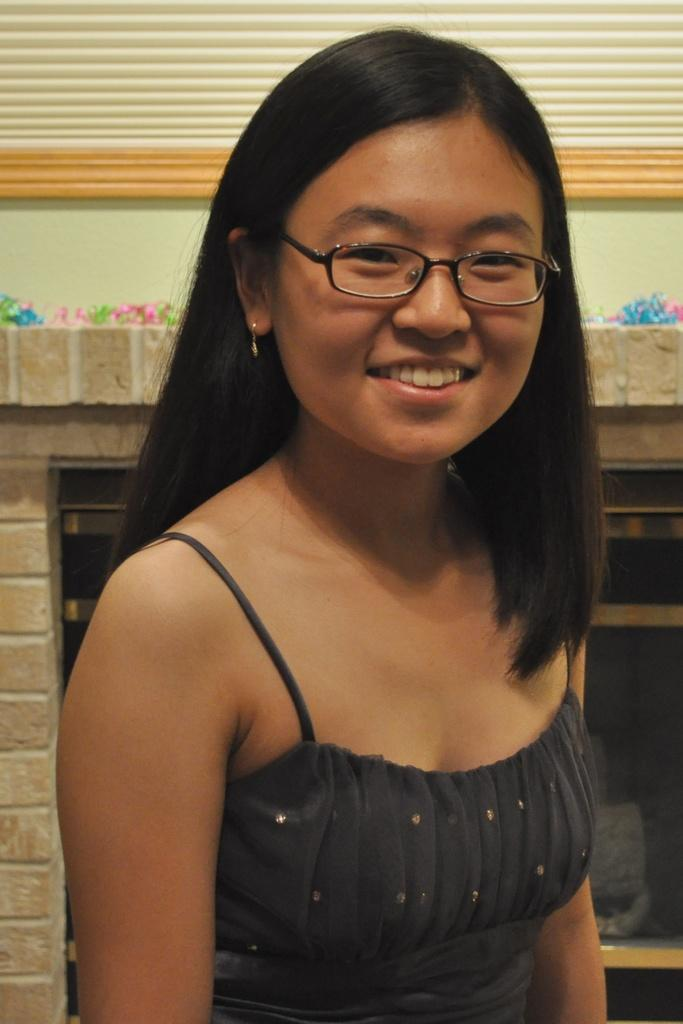Who is the main subject in the image? There is a woman in the image. What is the woman doing in the image? The woman is smiling. What accessory is the woman wearing in the image? The woman is wearing specs. What type of cloth is the woman using to cover the pest in the image? There is no cloth or pest present in the image. 